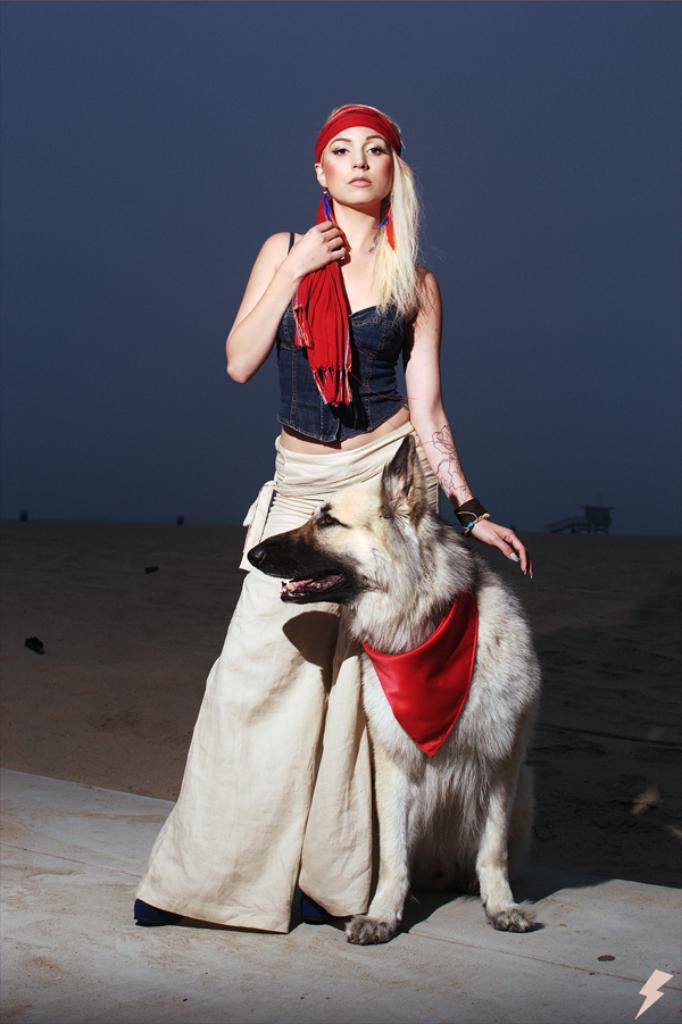Who is the main subject in the picture? There is a lady in the picture. What is the lady wearing on her upper body? The lady is wearing a black jacket. What is the lady wearing on her lower body? The lady is wearing cream pants. What is on the lady's head? The lady has a band on her head. What animal is beside the lady? There is a dog beside the lady. What type of fuel is the lady using to power her car in the image? There is no car present in the image, so it is not possible to determine what type of fuel the lady might be using. 